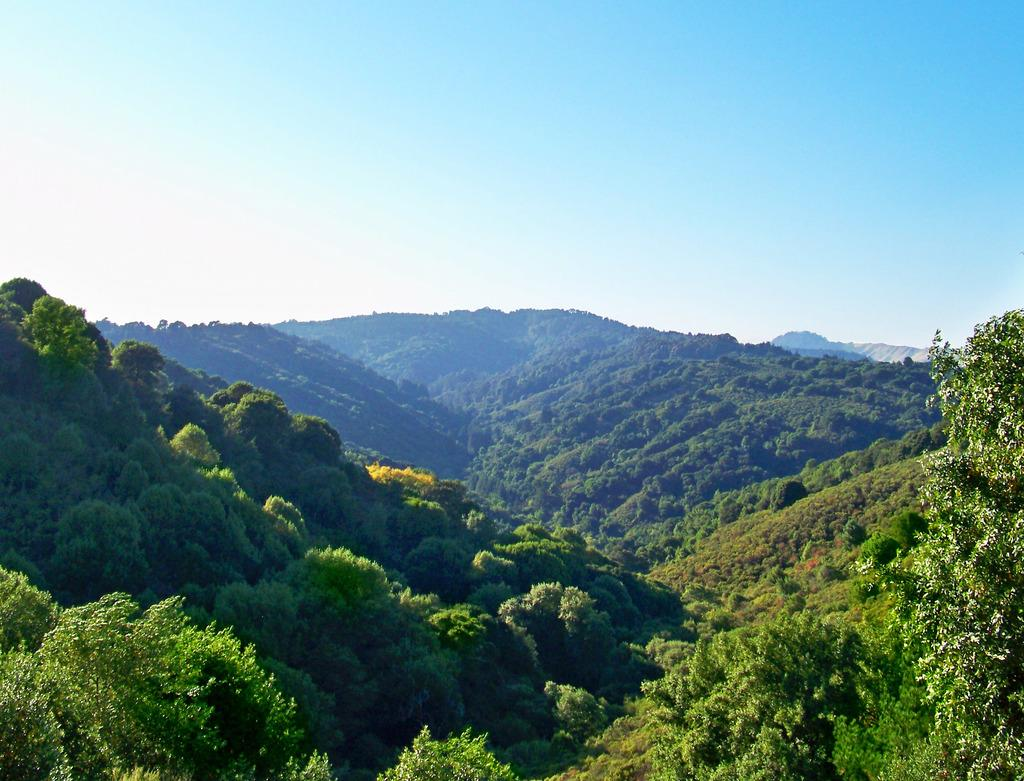What can be seen in the sky in the image? The sky is visible in the image, and clouds are present in the sky. What type of natural features can be seen in the image? There are hills and trees present in the image. What other types of vegetation can be seen in the image? Plants are visible in the image. How many cows are grazing in the library in the image? There are no cows or libraries present in the image. 